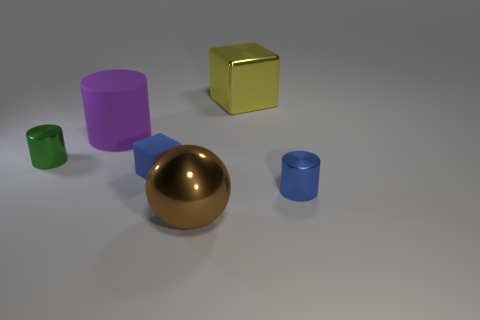Add 1 green metal balls. How many objects exist? 7 Subtract all balls. How many objects are left? 5 Subtract all big purple matte things. Subtract all large rubber balls. How many objects are left? 5 Add 1 tiny blue rubber things. How many tiny blue rubber things are left? 2 Add 3 green cylinders. How many green cylinders exist? 4 Subtract 0 purple spheres. How many objects are left? 6 